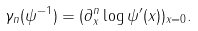<formula> <loc_0><loc_0><loc_500><loc_500>\gamma _ { n } ( \psi ^ { - 1 } ) = ( \partial _ { x } ^ { n } \log \psi ^ { \prime } ( x ) ) _ { x = 0 } .</formula> 